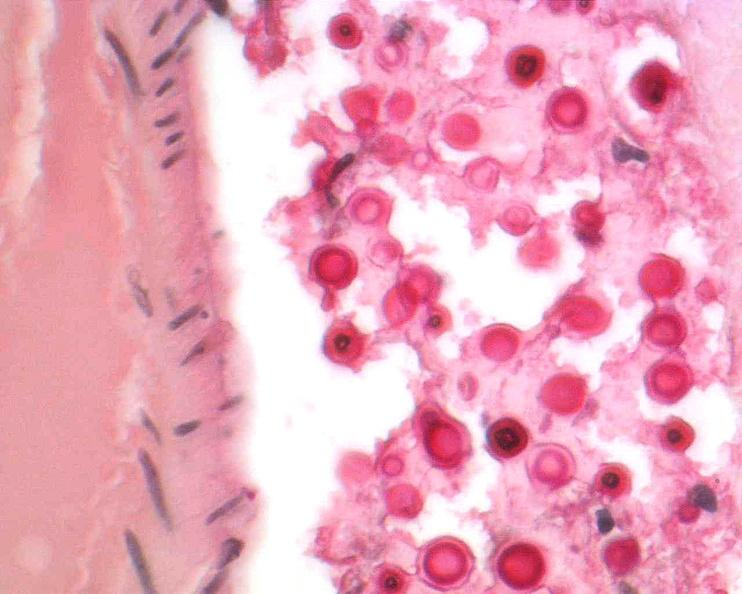what stain?
Answer the question using a single word or phrase. Mucicarmine 